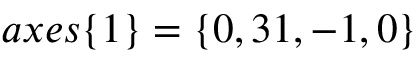<formula> <loc_0><loc_0><loc_500><loc_500>a x e s \{ 1 \} = \{ 0 , 3 1 , - 1 , 0 \}</formula> 